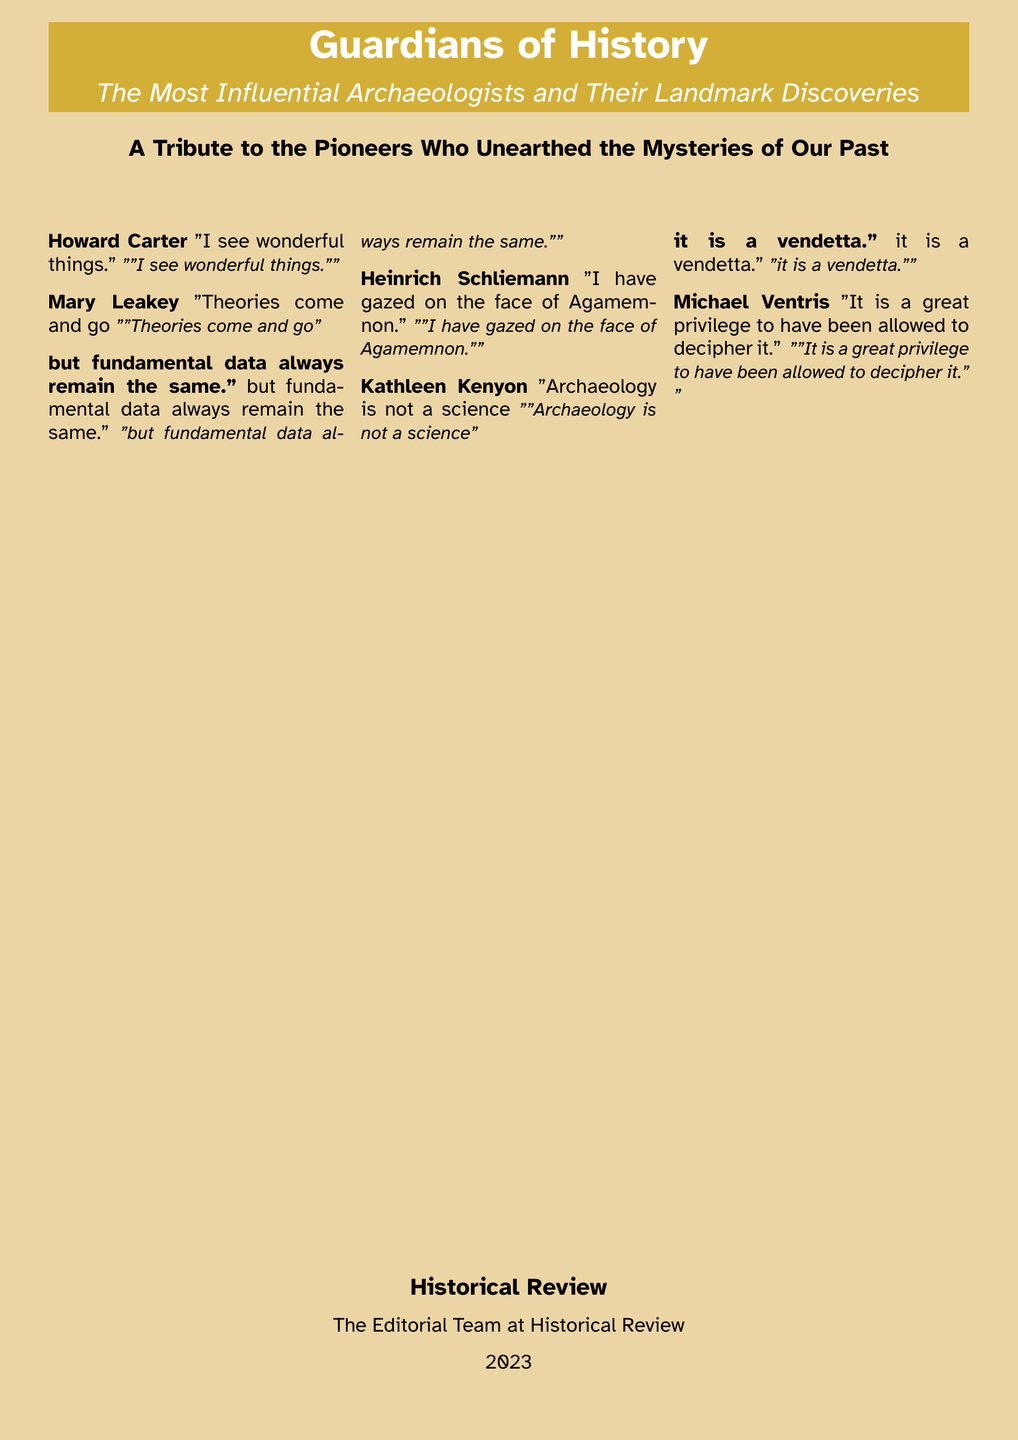What is the title of the book? The title is prominently displayed on the cover and is "Guardians of History".
Answer: Guardians of History Who is the first archaeologist mentioned? The first archaeologist's name is listed along with a quote in a structured format, which is Howard Carter.
Answer: Howard Carter What year is mentioned in the document? The year is indicated at the bottom of the document in the context of the editorial team, which is 2023.
Answer: 2023 How many archaeologists are quoted? The document lists a total of five prominent archaeologists quoted on the cover.
Answer: Five Which archaeologist stated, "I see wonderful things"? This specific quote is attributed to one of the featured archaeologists, which is Howard Carter.
Answer: Howard Carter What color is the background of the document? The background is specified in the document as being a color called sandstone.
Answer: Sandstone What type of document is this? The structure and content suggest that this is a book cover, specifically for a historical journal.
Answer: Book cover What is the subtitle of the book? The subtitle appears below the main title, providing additional context, which is "The Most Influential Archaeologists and Their Landmark Discoveries".
Answer: The Most Influential Archaeologists and Their Landmark Discoveries 